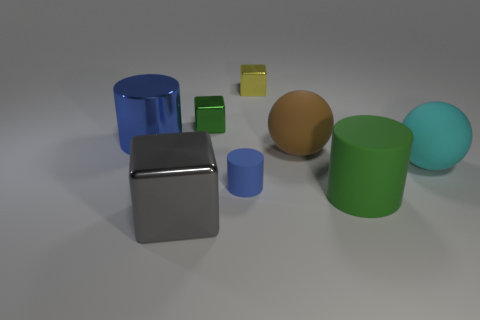Are there any blocks of the same color as the large matte cylinder?
Ensure brevity in your answer.  Yes. The ball that is the same material as the brown thing is what size?
Make the answer very short. Large. Is there any other thing that has the same color as the big cube?
Your answer should be very brief. No. There is a big ball in front of the large brown object; what color is it?
Your answer should be compact. Cyan. There is a big cylinder that is left of the rubber object in front of the tiny blue rubber thing; is there a metallic object that is on the right side of it?
Keep it short and to the point. Yes. Are there more green objects behind the brown matte sphere than large purple matte things?
Offer a very short reply. Yes. There is a rubber object to the right of the big rubber cylinder; does it have the same shape as the green rubber thing?
Keep it short and to the point. No. How many objects are either small gray things or blocks in front of the big blue metal cylinder?
Give a very brief answer. 1. How big is the shiny block that is both behind the big blue metal cylinder and on the left side of the yellow metal thing?
Give a very brief answer. Small. Is the number of rubber objects left of the cyan rubber ball greater than the number of large gray metallic blocks behind the tiny blue rubber cylinder?
Provide a succinct answer. Yes. 